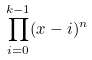<formula> <loc_0><loc_0><loc_500><loc_500>\prod _ { i = 0 } ^ { k - 1 } ( x - i ) ^ { n }</formula> 